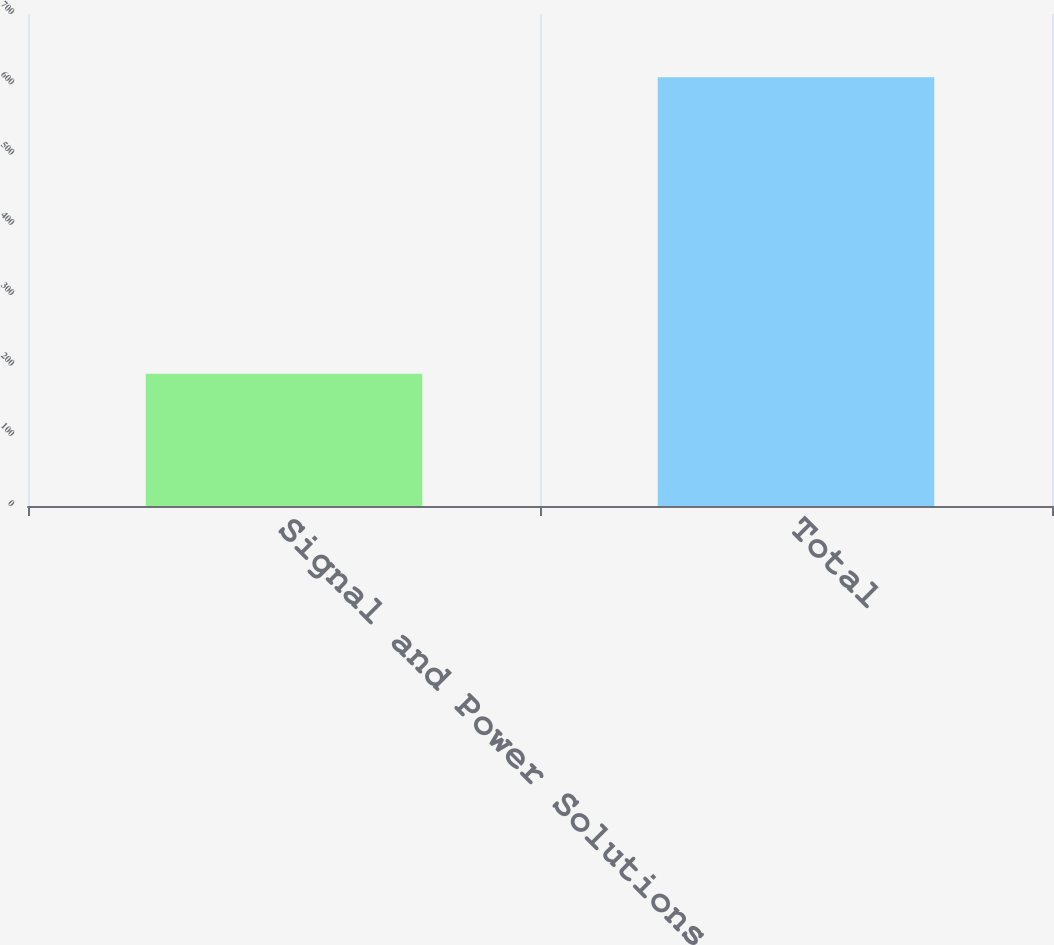Convert chart. <chart><loc_0><loc_0><loc_500><loc_500><bar_chart><fcel>Signal and Power Solutions<fcel>Total<nl><fcel>188<fcel>610<nl></chart> 